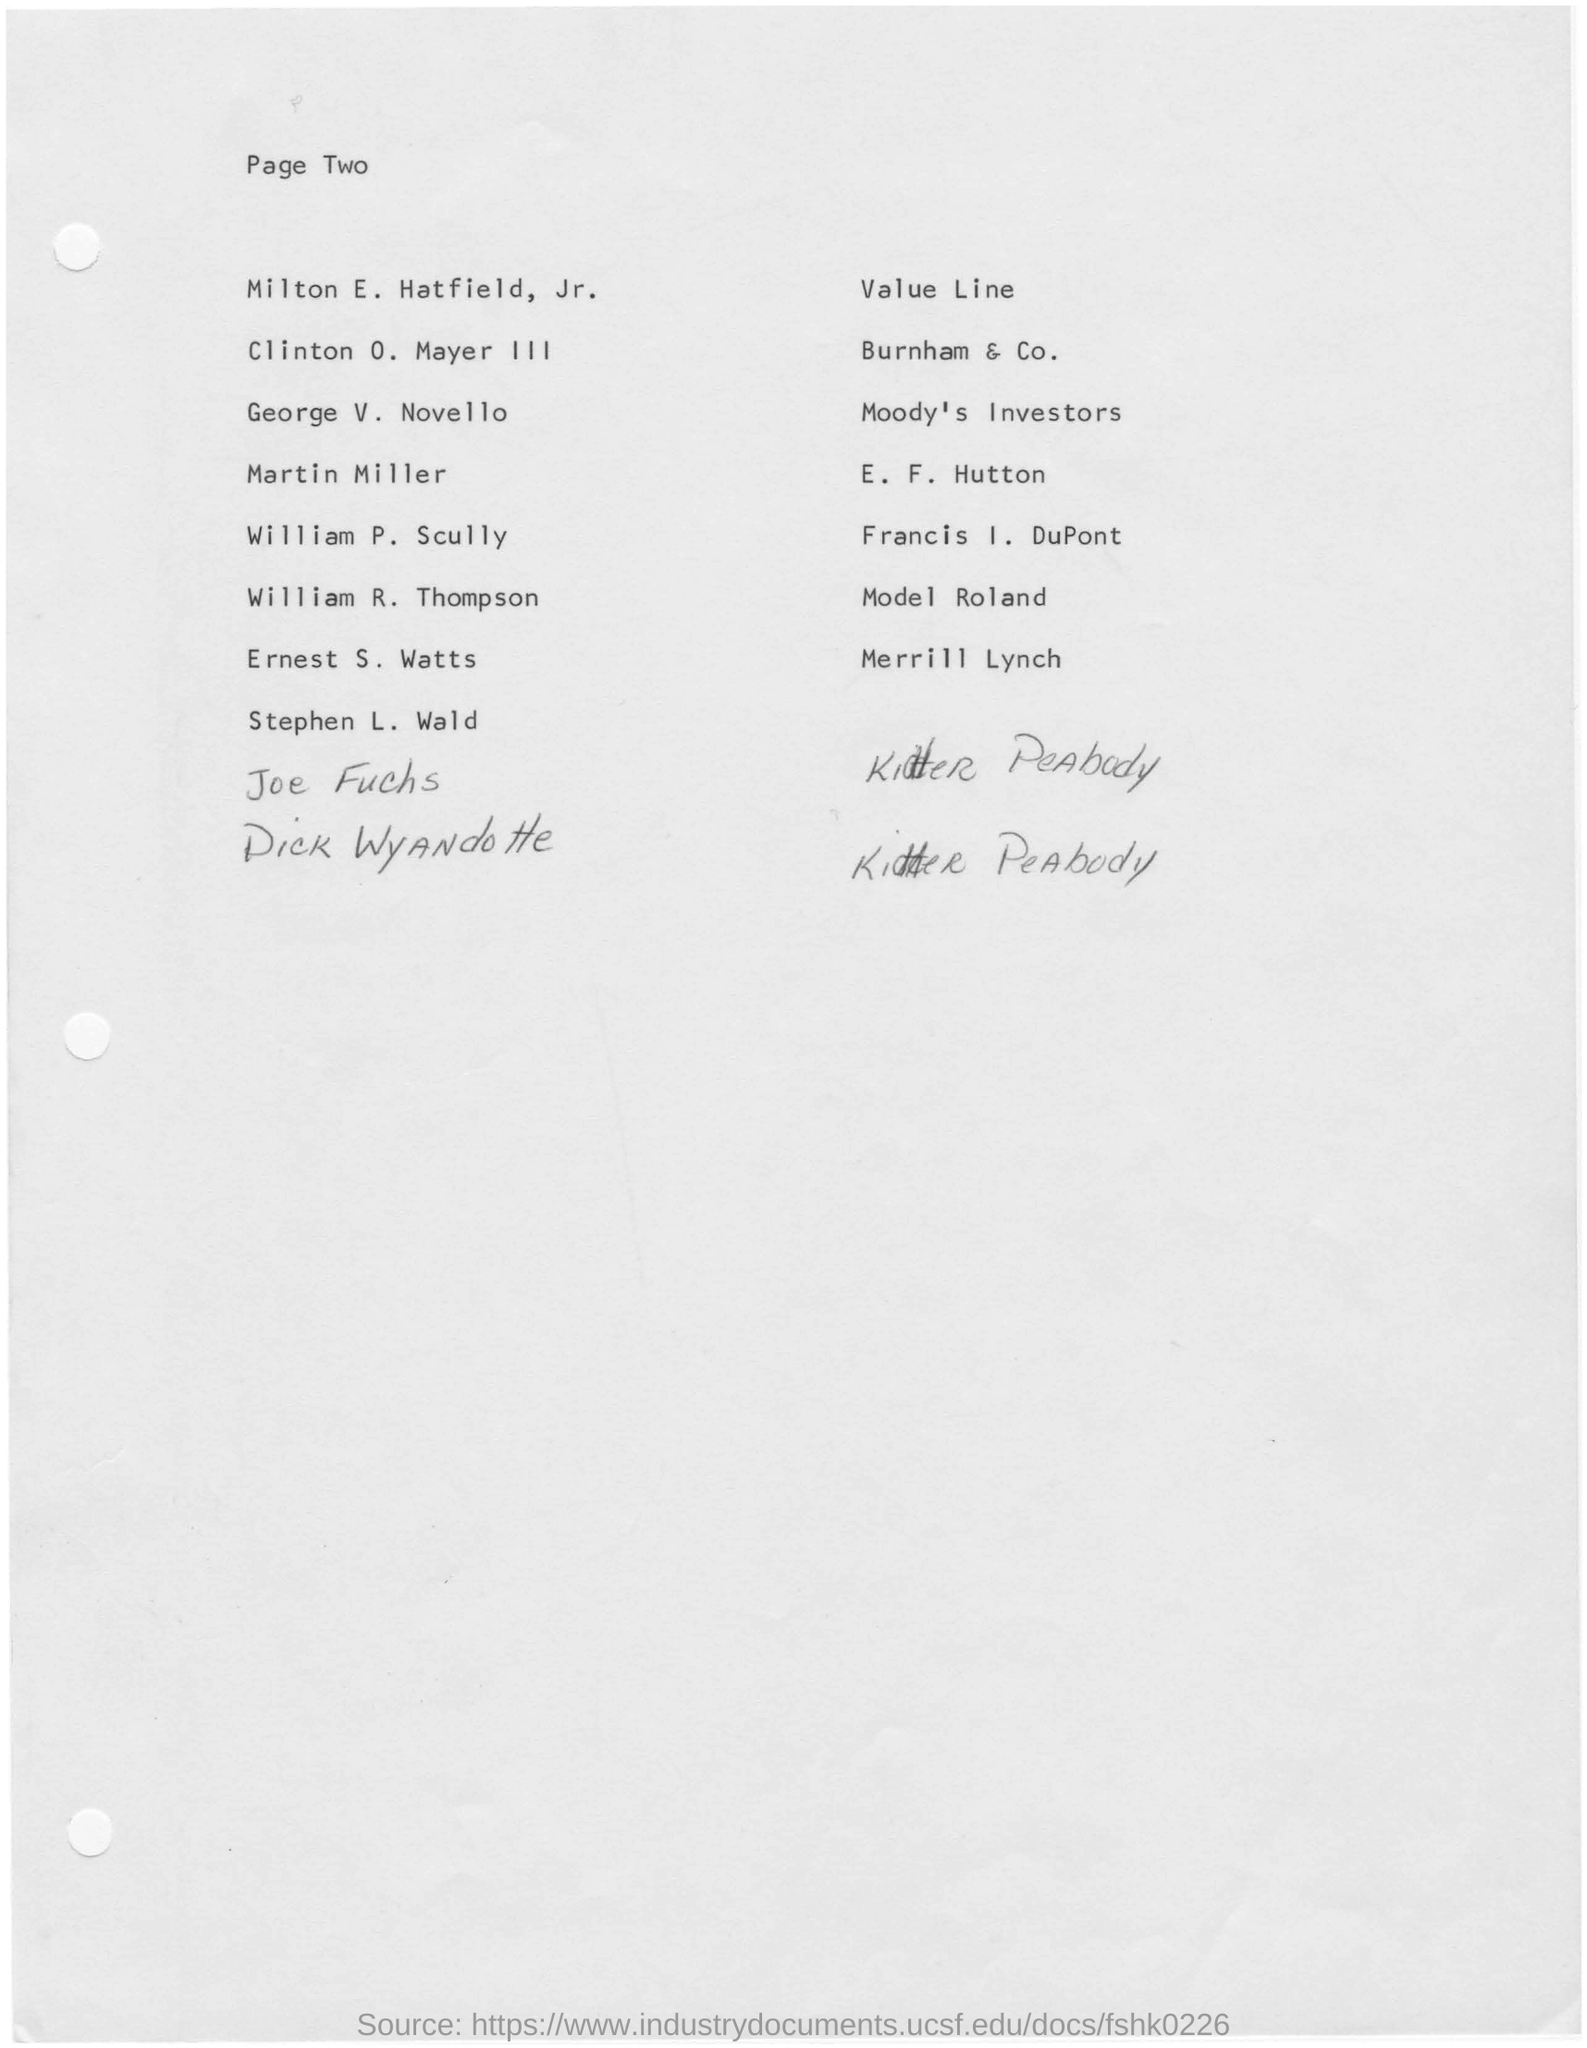Indicate a few pertinent items in this graphic. The page number mentioned in this document is Page Two. 